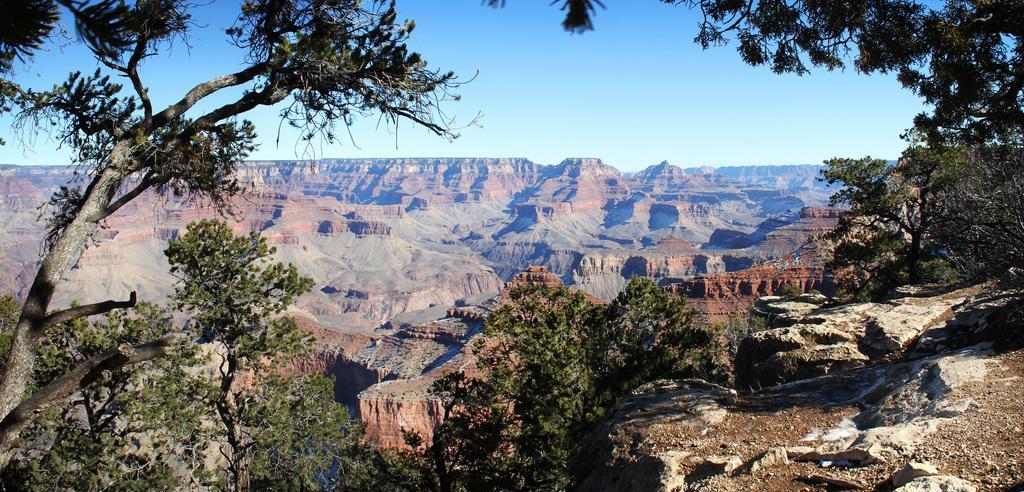Please provide a concise description of this image. These are the plateaus. I can see the trees with branches and leaves. This is the sky. 